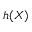Convert formula to latex. <formula><loc_0><loc_0><loc_500><loc_500>h ( X )</formula> 